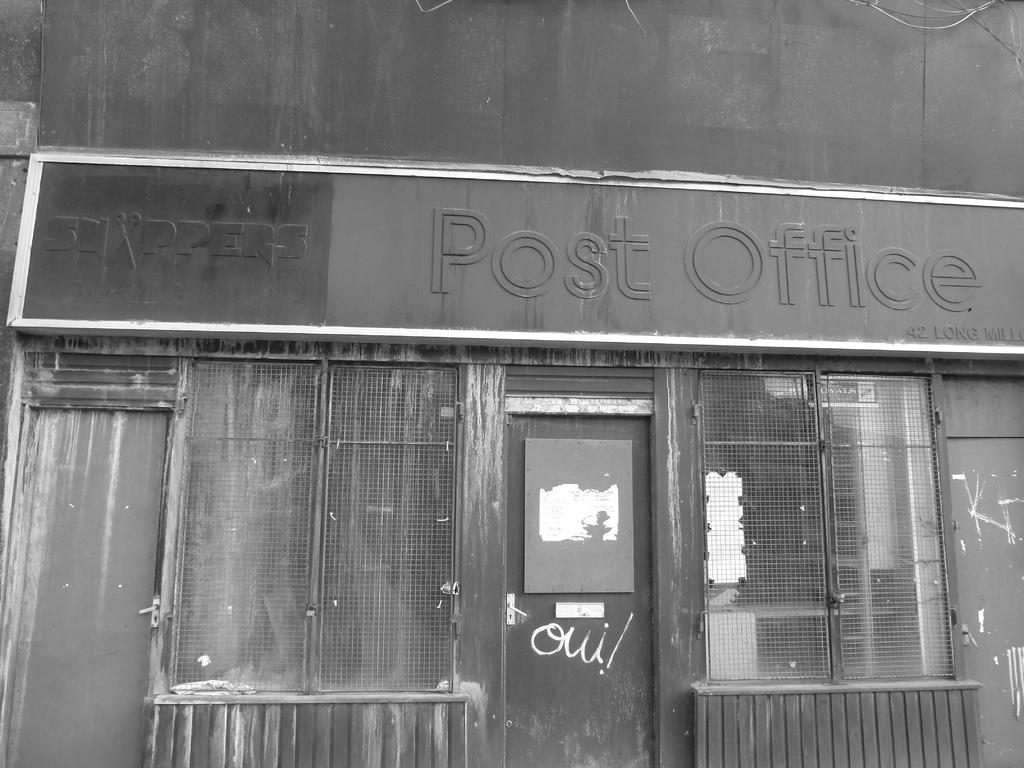What is on the wall of the building in the image? There is a board with text on the wall of a building. What architectural features can be seen in the image? There are doors and windows in the image. How many chairs are visible in the image? There are no chairs present in the image. What type of love can be seen expressed in the image? There is no expression of love present in the image. 